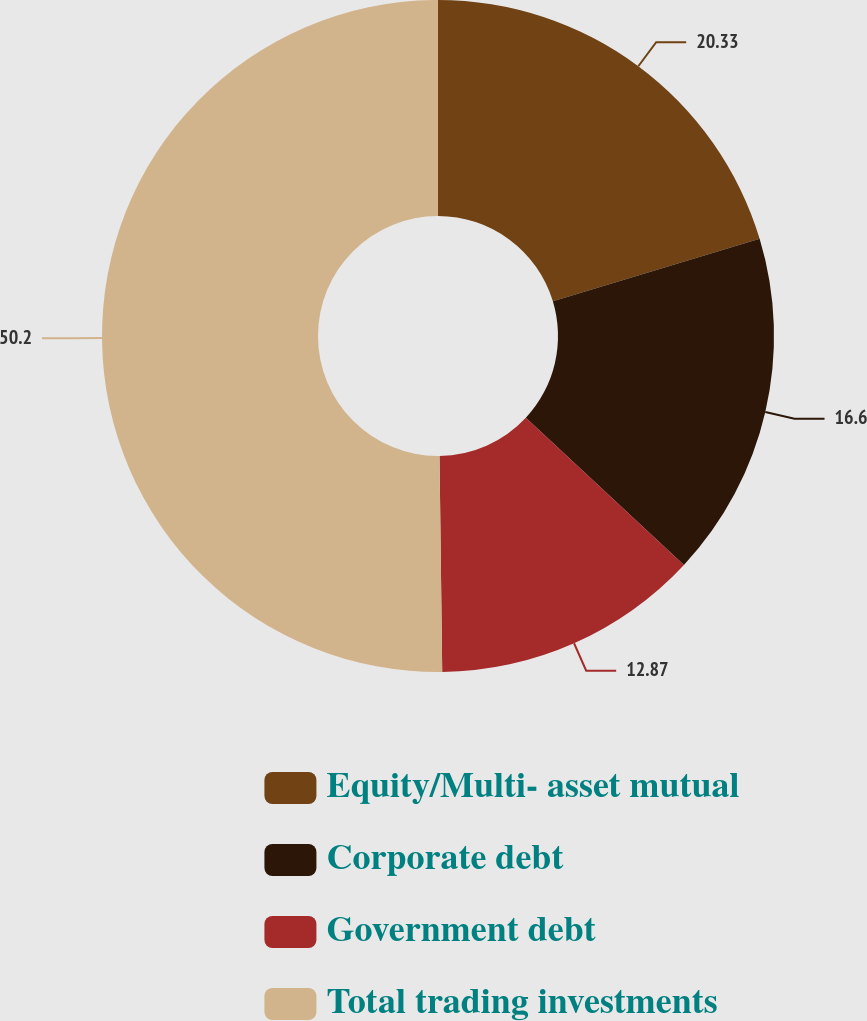Convert chart to OTSL. <chart><loc_0><loc_0><loc_500><loc_500><pie_chart><fcel>Equity/Multi- asset mutual<fcel>Corporate debt<fcel>Government debt<fcel>Total trading investments<nl><fcel>20.33%<fcel>16.6%<fcel>12.87%<fcel>50.2%<nl></chart> 